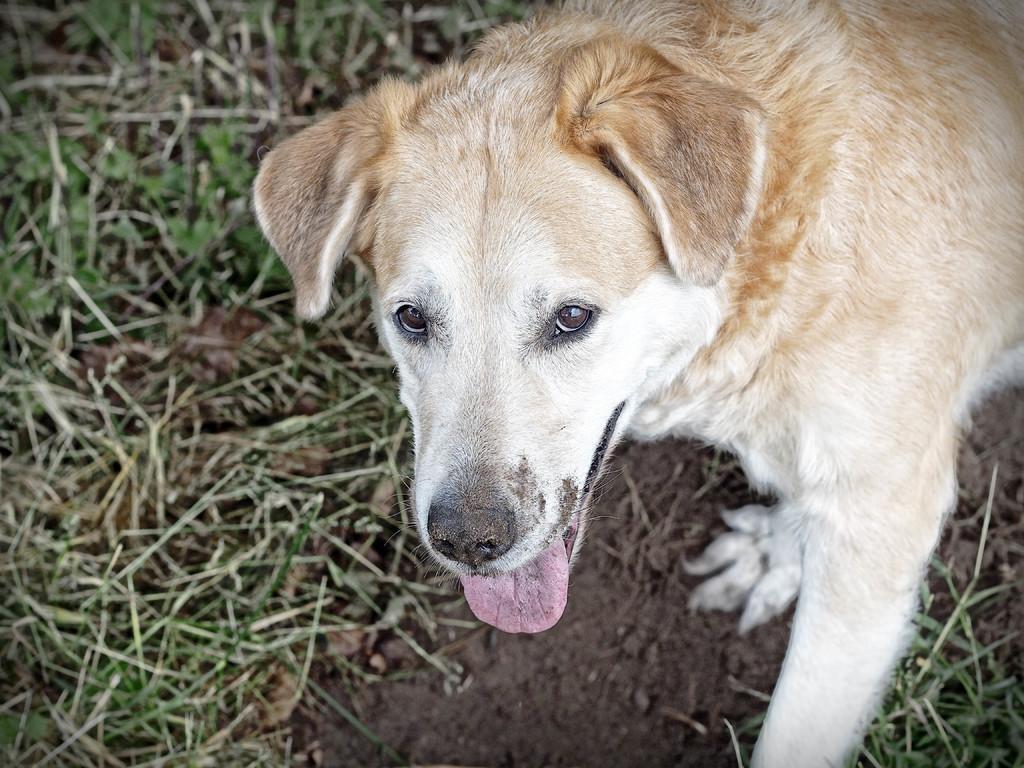Describe this image in one or two sentences. In this image there is a dog. At the bottom we can see grass. 